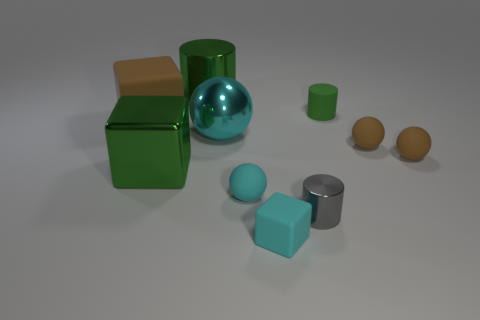Subtract all blue blocks. Subtract all green cylinders. How many blocks are left? 3 Subtract all balls. How many objects are left? 6 Subtract 0 purple cylinders. How many objects are left? 10 Subtract all large objects. Subtract all red shiny spheres. How many objects are left? 6 Add 6 small brown spheres. How many small brown spheres are left? 8 Add 7 large red rubber objects. How many large red rubber objects exist? 7 